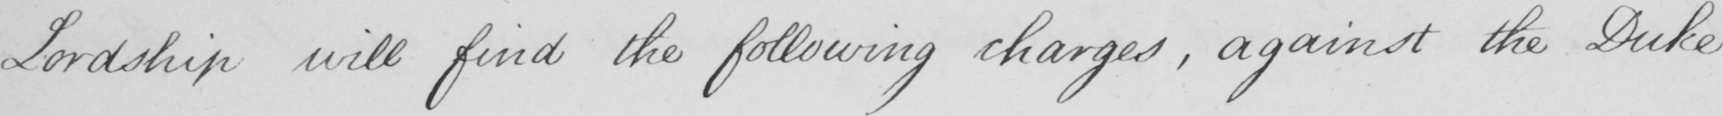What does this handwritten line say? Lordship will find the following charges , against the Duke 